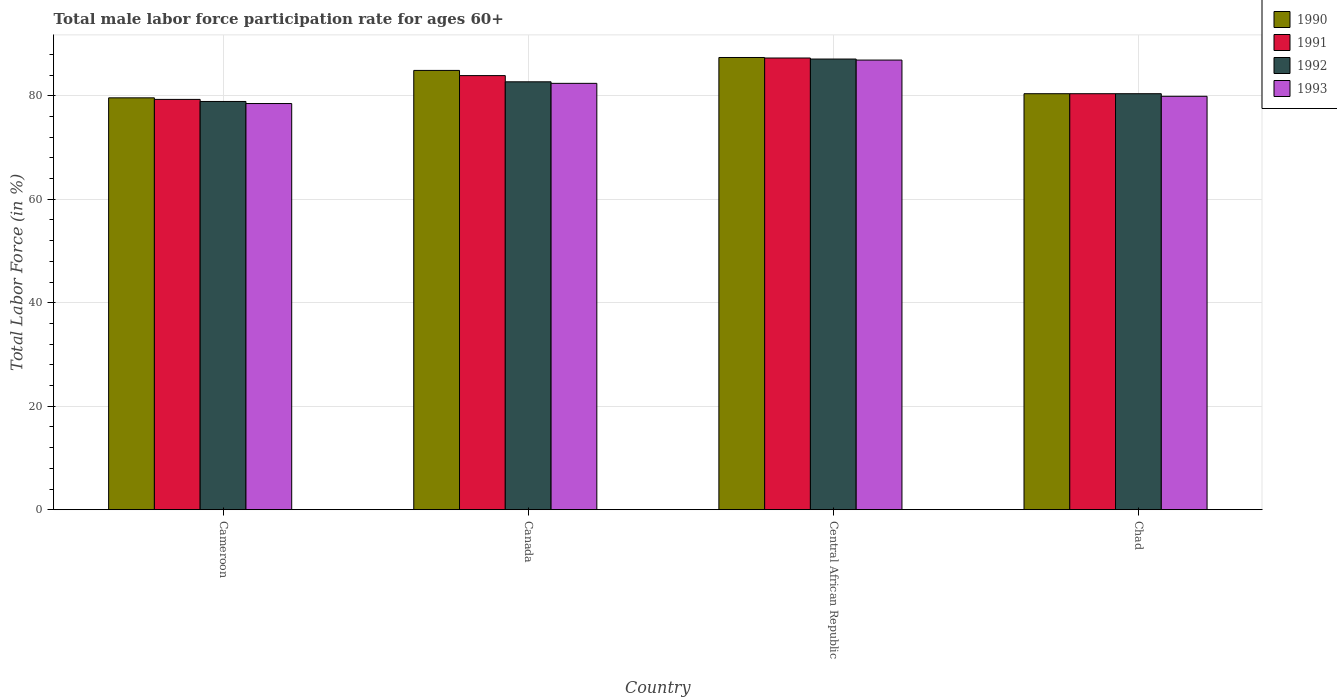How many different coloured bars are there?
Offer a very short reply. 4. Are the number of bars per tick equal to the number of legend labels?
Your answer should be very brief. Yes. Are the number of bars on each tick of the X-axis equal?
Make the answer very short. Yes. How many bars are there on the 3rd tick from the left?
Your answer should be very brief. 4. What is the male labor force participation rate in 1992 in Canada?
Your answer should be very brief. 82.7. Across all countries, what is the maximum male labor force participation rate in 1992?
Give a very brief answer. 87.1. Across all countries, what is the minimum male labor force participation rate in 1993?
Make the answer very short. 78.5. In which country was the male labor force participation rate in 1992 maximum?
Give a very brief answer. Central African Republic. In which country was the male labor force participation rate in 1991 minimum?
Provide a succinct answer. Cameroon. What is the total male labor force participation rate in 1991 in the graph?
Provide a succinct answer. 330.9. What is the difference between the male labor force participation rate in 1992 in Canada and that in Central African Republic?
Offer a very short reply. -4.4. What is the average male labor force participation rate in 1992 per country?
Make the answer very short. 82.27. What is the difference between the male labor force participation rate of/in 1992 and male labor force participation rate of/in 1993 in Canada?
Your response must be concise. 0.3. What is the ratio of the male labor force participation rate in 1993 in Canada to that in Chad?
Keep it short and to the point. 1.03. What is the difference between the highest and the second highest male labor force participation rate in 1993?
Make the answer very short. -4.5. What is the difference between the highest and the lowest male labor force participation rate in 1990?
Keep it short and to the point. 7.8. In how many countries, is the male labor force participation rate in 1992 greater than the average male labor force participation rate in 1992 taken over all countries?
Make the answer very short. 2. Is the sum of the male labor force participation rate in 1992 in Central African Republic and Chad greater than the maximum male labor force participation rate in 1991 across all countries?
Your answer should be very brief. Yes. Is it the case that in every country, the sum of the male labor force participation rate in 1993 and male labor force participation rate in 1991 is greater than the sum of male labor force participation rate in 1992 and male labor force participation rate in 1990?
Offer a terse response. No. What does the 3rd bar from the right in Canada represents?
Ensure brevity in your answer.  1991. Is it the case that in every country, the sum of the male labor force participation rate in 1992 and male labor force participation rate in 1990 is greater than the male labor force participation rate in 1991?
Your answer should be compact. Yes. How many countries are there in the graph?
Ensure brevity in your answer.  4. What is the difference between two consecutive major ticks on the Y-axis?
Provide a succinct answer. 20. Does the graph contain any zero values?
Your answer should be very brief. No. What is the title of the graph?
Provide a short and direct response. Total male labor force participation rate for ages 60+. Does "1997" appear as one of the legend labels in the graph?
Your answer should be very brief. No. What is the Total Labor Force (in %) in 1990 in Cameroon?
Ensure brevity in your answer.  79.6. What is the Total Labor Force (in %) in 1991 in Cameroon?
Give a very brief answer. 79.3. What is the Total Labor Force (in %) in 1992 in Cameroon?
Provide a succinct answer. 78.9. What is the Total Labor Force (in %) of 1993 in Cameroon?
Keep it short and to the point. 78.5. What is the Total Labor Force (in %) of 1990 in Canada?
Make the answer very short. 84.9. What is the Total Labor Force (in %) of 1991 in Canada?
Offer a very short reply. 83.9. What is the Total Labor Force (in %) of 1992 in Canada?
Your answer should be compact. 82.7. What is the Total Labor Force (in %) of 1993 in Canada?
Offer a terse response. 82.4. What is the Total Labor Force (in %) in 1990 in Central African Republic?
Give a very brief answer. 87.4. What is the Total Labor Force (in %) in 1991 in Central African Republic?
Keep it short and to the point. 87.3. What is the Total Labor Force (in %) in 1992 in Central African Republic?
Provide a short and direct response. 87.1. What is the Total Labor Force (in %) in 1993 in Central African Republic?
Keep it short and to the point. 86.9. What is the Total Labor Force (in %) in 1990 in Chad?
Provide a succinct answer. 80.4. What is the Total Labor Force (in %) of 1991 in Chad?
Provide a succinct answer. 80.4. What is the Total Labor Force (in %) in 1992 in Chad?
Keep it short and to the point. 80.4. What is the Total Labor Force (in %) in 1993 in Chad?
Your answer should be compact. 79.9. Across all countries, what is the maximum Total Labor Force (in %) in 1990?
Your response must be concise. 87.4. Across all countries, what is the maximum Total Labor Force (in %) of 1991?
Your answer should be compact. 87.3. Across all countries, what is the maximum Total Labor Force (in %) of 1992?
Keep it short and to the point. 87.1. Across all countries, what is the maximum Total Labor Force (in %) in 1993?
Offer a terse response. 86.9. Across all countries, what is the minimum Total Labor Force (in %) in 1990?
Offer a terse response. 79.6. Across all countries, what is the minimum Total Labor Force (in %) of 1991?
Your answer should be compact. 79.3. Across all countries, what is the minimum Total Labor Force (in %) of 1992?
Offer a terse response. 78.9. Across all countries, what is the minimum Total Labor Force (in %) of 1993?
Provide a succinct answer. 78.5. What is the total Total Labor Force (in %) of 1990 in the graph?
Ensure brevity in your answer.  332.3. What is the total Total Labor Force (in %) in 1991 in the graph?
Provide a short and direct response. 330.9. What is the total Total Labor Force (in %) in 1992 in the graph?
Ensure brevity in your answer.  329.1. What is the total Total Labor Force (in %) of 1993 in the graph?
Offer a terse response. 327.7. What is the difference between the Total Labor Force (in %) of 1990 in Cameroon and that in Canada?
Ensure brevity in your answer.  -5.3. What is the difference between the Total Labor Force (in %) of 1991 in Cameroon and that in Canada?
Provide a succinct answer. -4.6. What is the difference between the Total Labor Force (in %) in 1991 in Cameroon and that in Central African Republic?
Ensure brevity in your answer.  -8. What is the difference between the Total Labor Force (in %) in 1993 in Cameroon and that in Central African Republic?
Provide a short and direct response. -8.4. What is the difference between the Total Labor Force (in %) in 1990 in Cameroon and that in Chad?
Make the answer very short. -0.8. What is the difference between the Total Labor Force (in %) in 1991 in Cameroon and that in Chad?
Keep it short and to the point. -1.1. What is the difference between the Total Labor Force (in %) in 1990 in Canada and that in Central African Republic?
Offer a terse response. -2.5. What is the difference between the Total Labor Force (in %) of 1991 in Canada and that in Central African Republic?
Offer a terse response. -3.4. What is the difference between the Total Labor Force (in %) in 1993 in Canada and that in Central African Republic?
Provide a succinct answer. -4.5. What is the difference between the Total Labor Force (in %) of 1992 in Canada and that in Chad?
Your response must be concise. 2.3. What is the difference between the Total Labor Force (in %) of 1993 in Canada and that in Chad?
Provide a short and direct response. 2.5. What is the difference between the Total Labor Force (in %) in 1990 in Central African Republic and that in Chad?
Provide a succinct answer. 7. What is the difference between the Total Labor Force (in %) in 1992 in Central African Republic and that in Chad?
Your response must be concise. 6.7. What is the difference between the Total Labor Force (in %) in 1993 in Central African Republic and that in Chad?
Your response must be concise. 7. What is the difference between the Total Labor Force (in %) in 1990 in Cameroon and the Total Labor Force (in %) in 1992 in Canada?
Make the answer very short. -3.1. What is the difference between the Total Labor Force (in %) in 1991 in Cameroon and the Total Labor Force (in %) in 1992 in Canada?
Ensure brevity in your answer.  -3.4. What is the difference between the Total Labor Force (in %) of 1990 in Cameroon and the Total Labor Force (in %) of 1992 in Central African Republic?
Provide a short and direct response. -7.5. What is the difference between the Total Labor Force (in %) of 1990 in Cameroon and the Total Labor Force (in %) of 1993 in Central African Republic?
Keep it short and to the point. -7.3. What is the difference between the Total Labor Force (in %) in 1991 in Cameroon and the Total Labor Force (in %) in 1992 in Central African Republic?
Your response must be concise. -7.8. What is the difference between the Total Labor Force (in %) in 1991 in Cameroon and the Total Labor Force (in %) in 1993 in Central African Republic?
Offer a terse response. -7.6. What is the difference between the Total Labor Force (in %) of 1992 in Cameroon and the Total Labor Force (in %) of 1993 in Central African Republic?
Give a very brief answer. -8. What is the difference between the Total Labor Force (in %) in 1990 in Cameroon and the Total Labor Force (in %) in 1991 in Chad?
Your answer should be compact. -0.8. What is the difference between the Total Labor Force (in %) of 1990 in Cameroon and the Total Labor Force (in %) of 1992 in Chad?
Provide a succinct answer. -0.8. What is the difference between the Total Labor Force (in %) of 1991 in Cameroon and the Total Labor Force (in %) of 1993 in Chad?
Make the answer very short. -0.6. What is the difference between the Total Labor Force (in %) in 1992 in Cameroon and the Total Labor Force (in %) in 1993 in Chad?
Make the answer very short. -1. What is the difference between the Total Labor Force (in %) in 1990 in Canada and the Total Labor Force (in %) in 1991 in Central African Republic?
Ensure brevity in your answer.  -2.4. What is the difference between the Total Labor Force (in %) in 1991 in Canada and the Total Labor Force (in %) in 1992 in Central African Republic?
Keep it short and to the point. -3.2. What is the difference between the Total Labor Force (in %) in 1991 in Canada and the Total Labor Force (in %) in 1993 in Central African Republic?
Make the answer very short. -3. What is the difference between the Total Labor Force (in %) of 1992 in Canada and the Total Labor Force (in %) of 1993 in Central African Republic?
Provide a short and direct response. -4.2. What is the difference between the Total Labor Force (in %) of 1990 in Canada and the Total Labor Force (in %) of 1991 in Chad?
Make the answer very short. 4.5. What is the difference between the Total Labor Force (in %) in 1990 in Canada and the Total Labor Force (in %) in 1993 in Chad?
Offer a very short reply. 5. What is the difference between the Total Labor Force (in %) in 1991 in Canada and the Total Labor Force (in %) in 1992 in Chad?
Offer a terse response. 3.5. What is the difference between the Total Labor Force (in %) in 1991 in Canada and the Total Labor Force (in %) in 1993 in Chad?
Ensure brevity in your answer.  4. What is the difference between the Total Labor Force (in %) in 1990 in Central African Republic and the Total Labor Force (in %) in 1992 in Chad?
Offer a terse response. 7. What is the difference between the Total Labor Force (in %) in 1990 in Central African Republic and the Total Labor Force (in %) in 1993 in Chad?
Your answer should be very brief. 7.5. What is the difference between the Total Labor Force (in %) of 1991 in Central African Republic and the Total Labor Force (in %) of 1992 in Chad?
Your answer should be very brief. 6.9. What is the difference between the Total Labor Force (in %) in 1991 in Central African Republic and the Total Labor Force (in %) in 1993 in Chad?
Your answer should be compact. 7.4. What is the average Total Labor Force (in %) of 1990 per country?
Your response must be concise. 83.08. What is the average Total Labor Force (in %) of 1991 per country?
Your answer should be compact. 82.72. What is the average Total Labor Force (in %) in 1992 per country?
Give a very brief answer. 82.28. What is the average Total Labor Force (in %) in 1993 per country?
Ensure brevity in your answer.  81.92. What is the difference between the Total Labor Force (in %) in 1990 and Total Labor Force (in %) in 1992 in Cameroon?
Provide a short and direct response. 0.7. What is the difference between the Total Labor Force (in %) in 1991 and Total Labor Force (in %) in 1992 in Cameroon?
Give a very brief answer. 0.4. What is the difference between the Total Labor Force (in %) in 1991 and Total Labor Force (in %) in 1993 in Cameroon?
Offer a terse response. 0.8. What is the difference between the Total Labor Force (in %) in 1992 and Total Labor Force (in %) in 1993 in Cameroon?
Your answer should be compact. 0.4. What is the difference between the Total Labor Force (in %) in 1991 and Total Labor Force (in %) in 1992 in Canada?
Your answer should be very brief. 1.2. What is the difference between the Total Labor Force (in %) of 1991 and Total Labor Force (in %) of 1993 in Canada?
Offer a very short reply. 1.5. What is the difference between the Total Labor Force (in %) of 1990 and Total Labor Force (in %) of 1992 in Central African Republic?
Make the answer very short. 0.3. What is the difference between the Total Labor Force (in %) of 1991 and Total Labor Force (in %) of 1993 in Central African Republic?
Ensure brevity in your answer.  0.4. What is the difference between the Total Labor Force (in %) in 1992 and Total Labor Force (in %) in 1993 in Central African Republic?
Provide a succinct answer. 0.2. What is the difference between the Total Labor Force (in %) in 1990 and Total Labor Force (in %) in 1991 in Chad?
Provide a short and direct response. 0. What is the difference between the Total Labor Force (in %) in 1990 and Total Labor Force (in %) in 1992 in Chad?
Your response must be concise. 0. What is the difference between the Total Labor Force (in %) in 1990 and Total Labor Force (in %) in 1993 in Chad?
Your answer should be compact. 0.5. What is the difference between the Total Labor Force (in %) of 1991 and Total Labor Force (in %) of 1993 in Chad?
Your answer should be very brief. 0.5. What is the difference between the Total Labor Force (in %) in 1992 and Total Labor Force (in %) in 1993 in Chad?
Provide a succinct answer. 0.5. What is the ratio of the Total Labor Force (in %) of 1990 in Cameroon to that in Canada?
Provide a short and direct response. 0.94. What is the ratio of the Total Labor Force (in %) of 1991 in Cameroon to that in Canada?
Your answer should be very brief. 0.95. What is the ratio of the Total Labor Force (in %) in 1992 in Cameroon to that in Canada?
Offer a terse response. 0.95. What is the ratio of the Total Labor Force (in %) in 1993 in Cameroon to that in Canada?
Provide a succinct answer. 0.95. What is the ratio of the Total Labor Force (in %) in 1990 in Cameroon to that in Central African Republic?
Ensure brevity in your answer.  0.91. What is the ratio of the Total Labor Force (in %) in 1991 in Cameroon to that in Central African Republic?
Your response must be concise. 0.91. What is the ratio of the Total Labor Force (in %) in 1992 in Cameroon to that in Central African Republic?
Ensure brevity in your answer.  0.91. What is the ratio of the Total Labor Force (in %) of 1993 in Cameroon to that in Central African Republic?
Provide a succinct answer. 0.9. What is the ratio of the Total Labor Force (in %) of 1990 in Cameroon to that in Chad?
Provide a succinct answer. 0.99. What is the ratio of the Total Labor Force (in %) in 1991 in Cameroon to that in Chad?
Keep it short and to the point. 0.99. What is the ratio of the Total Labor Force (in %) of 1992 in Cameroon to that in Chad?
Provide a succinct answer. 0.98. What is the ratio of the Total Labor Force (in %) of 1993 in Cameroon to that in Chad?
Ensure brevity in your answer.  0.98. What is the ratio of the Total Labor Force (in %) of 1990 in Canada to that in Central African Republic?
Your response must be concise. 0.97. What is the ratio of the Total Labor Force (in %) in 1991 in Canada to that in Central African Republic?
Your answer should be compact. 0.96. What is the ratio of the Total Labor Force (in %) of 1992 in Canada to that in Central African Republic?
Give a very brief answer. 0.95. What is the ratio of the Total Labor Force (in %) in 1993 in Canada to that in Central African Republic?
Your answer should be very brief. 0.95. What is the ratio of the Total Labor Force (in %) of 1990 in Canada to that in Chad?
Offer a terse response. 1.06. What is the ratio of the Total Labor Force (in %) in 1991 in Canada to that in Chad?
Give a very brief answer. 1.04. What is the ratio of the Total Labor Force (in %) of 1992 in Canada to that in Chad?
Your answer should be compact. 1.03. What is the ratio of the Total Labor Force (in %) of 1993 in Canada to that in Chad?
Your answer should be compact. 1.03. What is the ratio of the Total Labor Force (in %) in 1990 in Central African Republic to that in Chad?
Ensure brevity in your answer.  1.09. What is the ratio of the Total Labor Force (in %) in 1991 in Central African Republic to that in Chad?
Offer a very short reply. 1.09. What is the ratio of the Total Labor Force (in %) of 1992 in Central African Republic to that in Chad?
Your response must be concise. 1.08. What is the ratio of the Total Labor Force (in %) in 1993 in Central African Republic to that in Chad?
Give a very brief answer. 1.09. What is the difference between the highest and the lowest Total Labor Force (in %) in 1992?
Give a very brief answer. 8.2. What is the difference between the highest and the lowest Total Labor Force (in %) of 1993?
Your answer should be very brief. 8.4. 